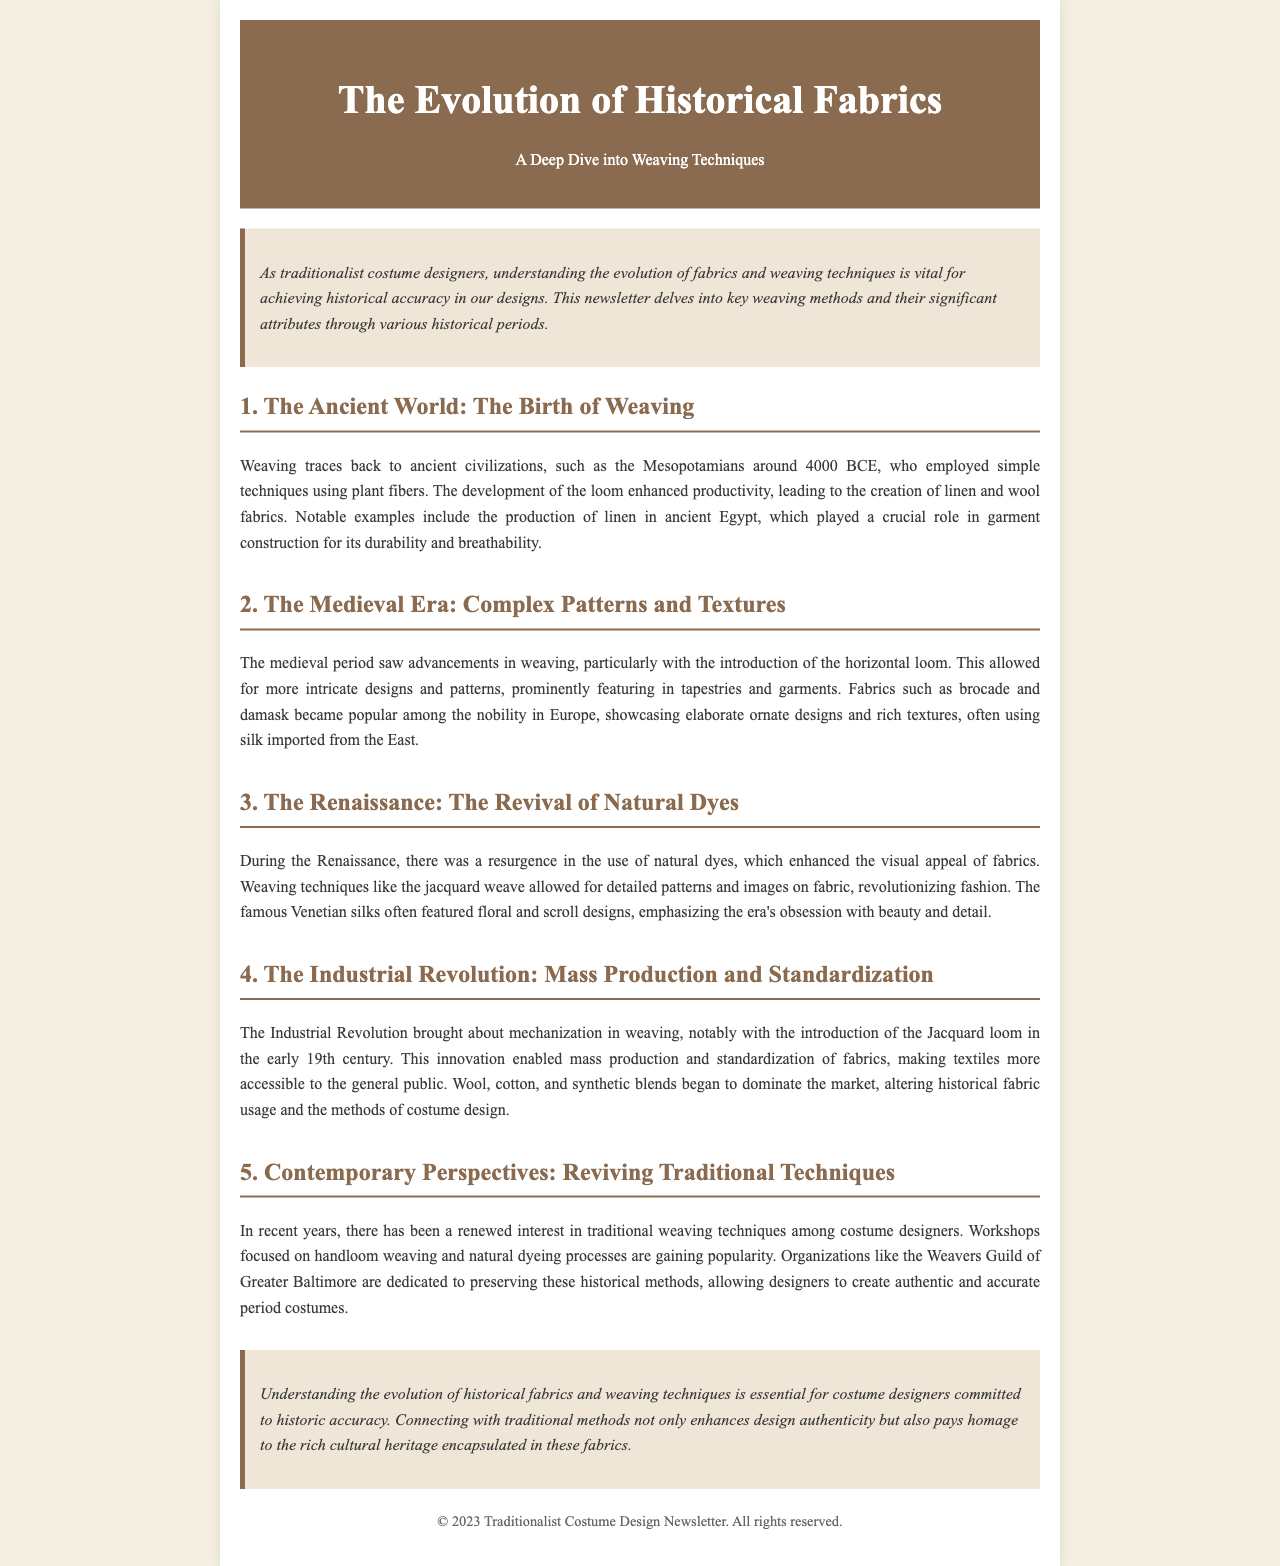What civilization first employed weaving techniques? The document mentions Mesopotamians around 4000 BCE as the first civilization to employ weaving techniques.
Answer: Mesopotamians What fabric became popular among the nobility during the medieval period? The medieval section highlights brocade and damask as popular fabrics among the nobility.
Answer: Brocade and damask What innovation allowed for mass production of fabrics during the Industrial Revolution? The introduction of the Jacquard loom in the early 19th century enabled mass production of fabrics.
Answer: Jacquard loom What weaving technique revolutionized fashion during the Renaissance? The document states that the jacquard weave allowed for detailed patterns and images on fabric, revolutionizing fashion.
Answer: Jacquard weave Which organization is mentioned as preserving traditional weaving methods? The Weavers Guild of Greater Baltimore is mentioned as an organization dedicated to preserving historical weaving methods.
Answer: Weavers Guild of Greater Baltimore How did the document describe the fabrics used in ancient Egypt? The document describes linen as crucial for its durability and breathability in garment construction in ancient Egypt.
Answer: Durability and breathability What era saw the revival of natural dyes? The Renaissance period is identified as the time when there was a resurgence in the use of natural dyes.
Answer: Renaissance What is the main focus of the newsletter? The primary focus of the newsletter is understanding the evolution of fabrics and weaving techniques for historic accuracy in costume design.
Answer: Historic accuracy in costume design 